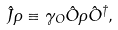<formula> <loc_0><loc_0><loc_500><loc_500>\hat { J } \rho \equiv \gamma _ { O } \hat { O } \rho \hat { O } ^ { \dagger } ,</formula> 